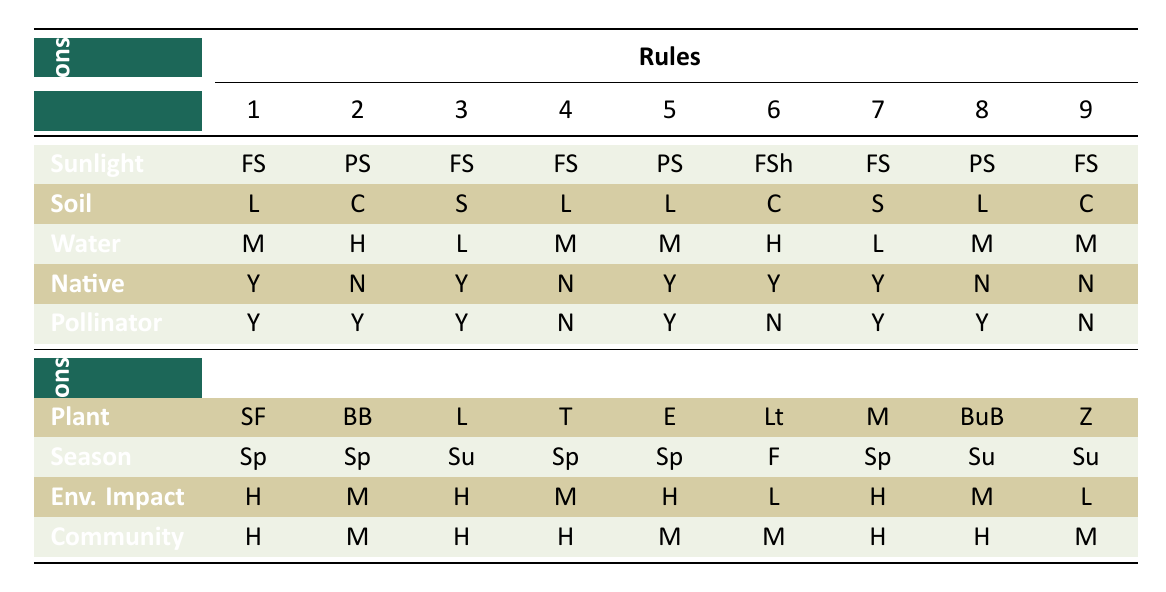What plants are recommended for 'Full Sun' and 'Loamy' soil? According to the table, under the 'Full Sun' and 'Loamy' conditions, the plants recommended are 'Sunflowers' and 'Tomatoes'.
Answer: Sunflowers, Tomatoes What is the planting season for 'Milkweed'? The table indicates that 'Milkweed', which grows in 'Full Sun', 'Sandy' soil, and has 'Low' water requirements, is best planted in 'Spring'.
Answer: Spring Are there any plants that are both native and pollinator-friendly? Yes, checking the table shows that 'Sunflowers', 'Lavender', 'Echinacea', and 'Milkweed' are all categorized as native to the local area and are also pollinator-friendly.
Answer: Yes Which plant has the lowest environmental impact? Looking through the environmental impact values, 'Lettuce' and 'Zucchini' are both categorized as having a 'Low' impact. Thus, they share the lowest environmental impact rating.
Answer: Lettuce, Zucchini What is the average community engagement potential for plants that need 'Moderate' water? Filtering through plants needing 'Moderate' water requirements, we find 'Sunflowers', 'Tomatoes', 'Echinacea', 'Butterfly Bush', and 'Kale'. Their community engagement potential ratings are 'High', 'High', 'Moderate', 'High', and 'Moderate', respectively. The average is (3 + 1 + 2 + 3 + 2) / 5 = 11 / 5 = 2.2, rounding gives us a score of 2 which is 'Moderate'.
Answer: Moderate Does any 'Partial Shade' plant have a 'High' environmental impact? After checking the table, 'Bee Balm' and 'Butterfly Bush' are both under 'Partial Shade', but only 'Bee Balm' has a 'Moderate' environmental impact and 'Butterfly Bush' is 'High'. Therefore, 'Butterfly Bush' is the only one with a high impact.
Answer: Yes 